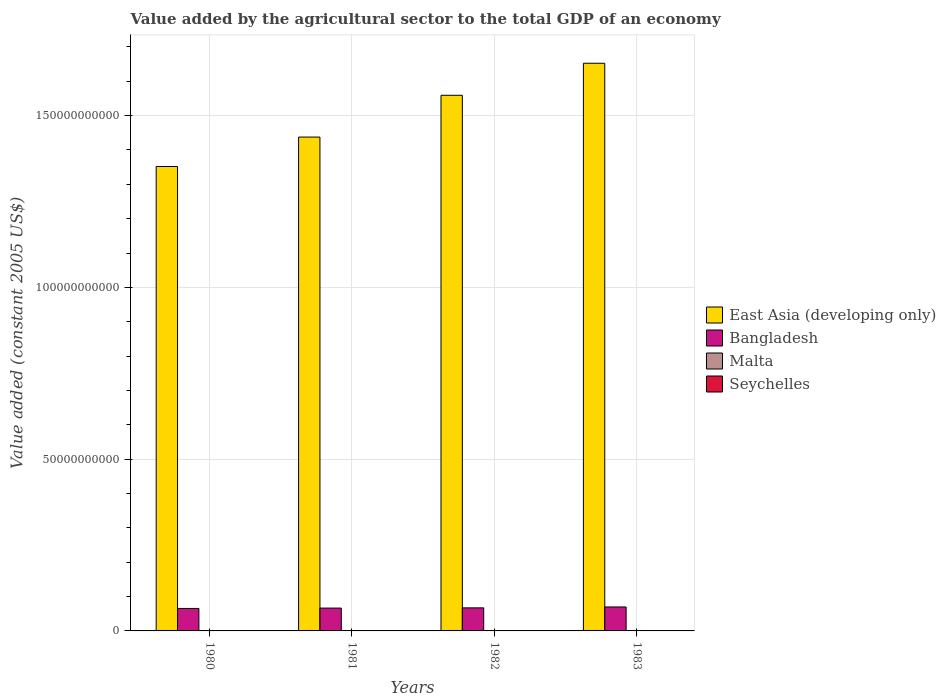How many groups of bars are there?
Your answer should be compact. 4. Are the number of bars per tick equal to the number of legend labels?
Make the answer very short. Yes. Are the number of bars on each tick of the X-axis equal?
Your answer should be compact. Yes. How many bars are there on the 2nd tick from the left?
Provide a short and direct response. 4. What is the label of the 4th group of bars from the left?
Your answer should be compact. 1983. What is the value added by the agricultural sector in Bangladesh in 1982?
Provide a succinct answer. 6.71e+09. Across all years, what is the maximum value added by the agricultural sector in Bangladesh?
Make the answer very short. 6.97e+09. Across all years, what is the minimum value added by the agricultural sector in Bangladesh?
Your response must be concise. 6.54e+09. In which year was the value added by the agricultural sector in Seychelles minimum?
Ensure brevity in your answer.  1982. What is the total value added by the agricultural sector in Bangladesh in the graph?
Give a very brief answer. 2.69e+1. What is the difference between the value added by the agricultural sector in Bangladesh in 1980 and that in 1983?
Offer a terse response. -4.32e+08. What is the difference between the value added by the agricultural sector in Bangladesh in 1981 and the value added by the agricultural sector in East Asia (developing only) in 1980?
Your response must be concise. -1.29e+11. What is the average value added by the agricultural sector in Bangladesh per year?
Ensure brevity in your answer.  6.72e+09. In the year 1980, what is the difference between the value added by the agricultural sector in Seychelles and value added by the agricultural sector in Bangladesh?
Ensure brevity in your answer.  -6.51e+09. What is the ratio of the value added by the agricultural sector in Bangladesh in 1981 to that in 1983?
Provide a short and direct response. 0.95. Is the value added by the agricultural sector in Seychelles in 1980 less than that in 1983?
Your response must be concise. Yes. Is the difference between the value added by the agricultural sector in Seychelles in 1980 and 1983 greater than the difference between the value added by the agricultural sector in Bangladesh in 1980 and 1983?
Your response must be concise. Yes. What is the difference between the highest and the second highest value added by the agricultural sector in Malta?
Offer a terse response. 1.11e+07. What is the difference between the highest and the lowest value added by the agricultural sector in Bangladesh?
Make the answer very short. 4.32e+08. In how many years, is the value added by the agricultural sector in Bangladesh greater than the average value added by the agricultural sector in Bangladesh taken over all years?
Keep it short and to the point. 1. What does the 1st bar from the right in 1981 represents?
Your answer should be compact. Seychelles. Is it the case that in every year, the sum of the value added by the agricultural sector in East Asia (developing only) and value added by the agricultural sector in Bangladesh is greater than the value added by the agricultural sector in Malta?
Your answer should be compact. Yes. How many bars are there?
Your answer should be very brief. 16. Are all the bars in the graph horizontal?
Your answer should be compact. No. Are the values on the major ticks of Y-axis written in scientific E-notation?
Offer a terse response. No. Does the graph contain any zero values?
Give a very brief answer. No. Does the graph contain grids?
Keep it short and to the point. Yes. Where does the legend appear in the graph?
Provide a succinct answer. Center right. How many legend labels are there?
Make the answer very short. 4. How are the legend labels stacked?
Provide a succinct answer. Vertical. What is the title of the graph?
Your answer should be compact. Value added by the agricultural sector to the total GDP of an economy. Does "Dominican Republic" appear as one of the legend labels in the graph?
Offer a very short reply. No. What is the label or title of the Y-axis?
Provide a succinct answer. Value added (constant 2005 US$). What is the Value added (constant 2005 US$) in East Asia (developing only) in 1980?
Ensure brevity in your answer.  1.35e+11. What is the Value added (constant 2005 US$) of Bangladesh in 1980?
Offer a very short reply. 6.54e+09. What is the Value added (constant 2005 US$) in Malta in 1980?
Your response must be concise. 8.12e+07. What is the Value added (constant 2005 US$) in Seychelles in 1980?
Provide a short and direct response. 3.19e+07. What is the Value added (constant 2005 US$) in East Asia (developing only) in 1981?
Provide a succinct answer. 1.44e+11. What is the Value added (constant 2005 US$) in Bangladesh in 1981?
Your answer should be compact. 6.65e+09. What is the Value added (constant 2005 US$) of Malta in 1981?
Give a very brief answer. 8.53e+07. What is the Value added (constant 2005 US$) in Seychelles in 1981?
Give a very brief answer. 3.42e+07. What is the Value added (constant 2005 US$) of East Asia (developing only) in 1982?
Provide a succinct answer. 1.56e+11. What is the Value added (constant 2005 US$) in Bangladesh in 1982?
Offer a terse response. 6.71e+09. What is the Value added (constant 2005 US$) in Malta in 1982?
Make the answer very short. 9.19e+07. What is the Value added (constant 2005 US$) of Seychelles in 1982?
Your response must be concise. 2.65e+07. What is the Value added (constant 2005 US$) of East Asia (developing only) in 1983?
Give a very brief answer. 1.65e+11. What is the Value added (constant 2005 US$) of Bangladesh in 1983?
Give a very brief answer. 6.97e+09. What is the Value added (constant 2005 US$) in Malta in 1983?
Provide a succinct answer. 1.03e+08. What is the Value added (constant 2005 US$) of Seychelles in 1983?
Make the answer very short. 3.30e+07. Across all years, what is the maximum Value added (constant 2005 US$) of East Asia (developing only)?
Give a very brief answer. 1.65e+11. Across all years, what is the maximum Value added (constant 2005 US$) of Bangladesh?
Your answer should be very brief. 6.97e+09. Across all years, what is the maximum Value added (constant 2005 US$) of Malta?
Make the answer very short. 1.03e+08. Across all years, what is the maximum Value added (constant 2005 US$) in Seychelles?
Your answer should be very brief. 3.42e+07. Across all years, what is the minimum Value added (constant 2005 US$) in East Asia (developing only)?
Make the answer very short. 1.35e+11. Across all years, what is the minimum Value added (constant 2005 US$) in Bangladesh?
Offer a terse response. 6.54e+09. Across all years, what is the minimum Value added (constant 2005 US$) of Malta?
Give a very brief answer. 8.12e+07. Across all years, what is the minimum Value added (constant 2005 US$) of Seychelles?
Your answer should be very brief. 2.65e+07. What is the total Value added (constant 2005 US$) in East Asia (developing only) in the graph?
Your answer should be compact. 6.00e+11. What is the total Value added (constant 2005 US$) in Bangladesh in the graph?
Give a very brief answer. 2.69e+1. What is the total Value added (constant 2005 US$) in Malta in the graph?
Ensure brevity in your answer.  3.61e+08. What is the total Value added (constant 2005 US$) of Seychelles in the graph?
Offer a terse response. 1.26e+08. What is the difference between the Value added (constant 2005 US$) in East Asia (developing only) in 1980 and that in 1981?
Ensure brevity in your answer.  -8.57e+09. What is the difference between the Value added (constant 2005 US$) of Bangladesh in 1980 and that in 1981?
Your answer should be compact. -1.03e+08. What is the difference between the Value added (constant 2005 US$) in Malta in 1980 and that in 1981?
Your answer should be very brief. -4.05e+06. What is the difference between the Value added (constant 2005 US$) in Seychelles in 1980 and that in 1981?
Your response must be concise. -2.31e+06. What is the difference between the Value added (constant 2005 US$) in East Asia (developing only) in 1980 and that in 1982?
Give a very brief answer. -2.07e+1. What is the difference between the Value added (constant 2005 US$) of Bangladesh in 1980 and that in 1982?
Provide a succinct answer. -1.71e+08. What is the difference between the Value added (constant 2005 US$) of Malta in 1980 and that in 1982?
Offer a terse response. -1.07e+07. What is the difference between the Value added (constant 2005 US$) of Seychelles in 1980 and that in 1982?
Ensure brevity in your answer.  5.41e+06. What is the difference between the Value added (constant 2005 US$) in East Asia (developing only) in 1980 and that in 1983?
Your answer should be compact. -3.01e+1. What is the difference between the Value added (constant 2005 US$) of Bangladesh in 1980 and that in 1983?
Give a very brief answer. -4.32e+08. What is the difference between the Value added (constant 2005 US$) of Malta in 1980 and that in 1983?
Offer a very short reply. -2.18e+07. What is the difference between the Value added (constant 2005 US$) of Seychelles in 1980 and that in 1983?
Provide a short and direct response. -1.09e+06. What is the difference between the Value added (constant 2005 US$) in East Asia (developing only) in 1981 and that in 1982?
Your answer should be compact. -1.22e+1. What is the difference between the Value added (constant 2005 US$) in Bangladesh in 1981 and that in 1982?
Your answer should be very brief. -6.80e+07. What is the difference between the Value added (constant 2005 US$) of Malta in 1981 and that in 1982?
Provide a succinct answer. -6.64e+06. What is the difference between the Value added (constant 2005 US$) of Seychelles in 1981 and that in 1982?
Keep it short and to the point. 7.73e+06. What is the difference between the Value added (constant 2005 US$) of East Asia (developing only) in 1981 and that in 1983?
Make the answer very short. -2.15e+1. What is the difference between the Value added (constant 2005 US$) of Bangladesh in 1981 and that in 1983?
Make the answer very short. -3.29e+08. What is the difference between the Value added (constant 2005 US$) of Malta in 1981 and that in 1983?
Ensure brevity in your answer.  -1.77e+07. What is the difference between the Value added (constant 2005 US$) of Seychelles in 1981 and that in 1983?
Offer a terse response. 1.23e+06. What is the difference between the Value added (constant 2005 US$) in East Asia (developing only) in 1982 and that in 1983?
Offer a very short reply. -9.32e+09. What is the difference between the Value added (constant 2005 US$) in Bangladesh in 1982 and that in 1983?
Ensure brevity in your answer.  -2.61e+08. What is the difference between the Value added (constant 2005 US$) of Malta in 1982 and that in 1983?
Provide a succinct answer. -1.11e+07. What is the difference between the Value added (constant 2005 US$) in Seychelles in 1982 and that in 1983?
Offer a terse response. -6.50e+06. What is the difference between the Value added (constant 2005 US$) of East Asia (developing only) in 1980 and the Value added (constant 2005 US$) of Bangladesh in 1981?
Ensure brevity in your answer.  1.29e+11. What is the difference between the Value added (constant 2005 US$) in East Asia (developing only) in 1980 and the Value added (constant 2005 US$) in Malta in 1981?
Provide a succinct answer. 1.35e+11. What is the difference between the Value added (constant 2005 US$) in East Asia (developing only) in 1980 and the Value added (constant 2005 US$) in Seychelles in 1981?
Provide a short and direct response. 1.35e+11. What is the difference between the Value added (constant 2005 US$) of Bangladesh in 1980 and the Value added (constant 2005 US$) of Malta in 1981?
Provide a succinct answer. 6.46e+09. What is the difference between the Value added (constant 2005 US$) of Bangladesh in 1980 and the Value added (constant 2005 US$) of Seychelles in 1981?
Make the answer very short. 6.51e+09. What is the difference between the Value added (constant 2005 US$) in Malta in 1980 and the Value added (constant 2005 US$) in Seychelles in 1981?
Provide a short and direct response. 4.70e+07. What is the difference between the Value added (constant 2005 US$) of East Asia (developing only) in 1980 and the Value added (constant 2005 US$) of Bangladesh in 1982?
Offer a very short reply. 1.28e+11. What is the difference between the Value added (constant 2005 US$) in East Asia (developing only) in 1980 and the Value added (constant 2005 US$) in Malta in 1982?
Offer a very short reply. 1.35e+11. What is the difference between the Value added (constant 2005 US$) in East Asia (developing only) in 1980 and the Value added (constant 2005 US$) in Seychelles in 1982?
Offer a terse response. 1.35e+11. What is the difference between the Value added (constant 2005 US$) of Bangladesh in 1980 and the Value added (constant 2005 US$) of Malta in 1982?
Your answer should be very brief. 6.45e+09. What is the difference between the Value added (constant 2005 US$) of Bangladesh in 1980 and the Value added (constant 2005 US$) of Seychelles in 1982?
Your answer should be compact. 6.52e+09. What is the difference between the Value added (constant 2005 US$) in Malta in 1980 and the Value added (constant 2005 US$) in Seychelles in 1982?
Your response must be concise. 5.47e+07. What is the difference between the Value added (constant 2005 US$) in East Asia (developing only) in 1980 and the Value added (constant 2005 US$) in Bangladesh in 1983?
Provide a succinct answer. 1.28e+11. What is the difference between the Value added (constant 2005 US$) in East Asia (developing only) in 1980 and the Value added (constant 2005 US$) in Malta in 1983?
Your answer should be very brief. 1.35e+11. What is the difference between the Value added (constant 2005 US$) of East Asia (developing only) in 1980 and the Value added (constant 2005 US$) of Seychelles in 1983?
Provide a short and direct response. 1.35e+11. What is the difference between the Value added (constant 2005 US$) of Bangladesh in 1980 and the Value added (constant 2005 US$) of Malta in 1983?
Offer a very short reply. 6.44e+09. What is the difference between the Value added (constant 2005 US$) in Bangladesh in 1980 and the Value added (constant 2005 US$) in Seychelles in 1983?
Ensure brevity in your answer.  6.51e+09. What is the difference between the Value added (constant 2005 US$) of Malta in 1980 and the Value added (constant 2005 US$) of Seychelles in 1983?
Keep it short and to the point. 4.82e+07. What is the difference between the Value added (constant 2005 US$) in East Asia (developing only) in 1981 and the Value added (constant 2005 US$) in Bangladesh in 1982?
Provide a succinct answer. 1.37e+11. What is the difference between the Value added (constant 2005 US$) in East Asia (developing only) in 1981 and the Value added (constant 2005 US$) in Malta in 1982?
Provide a short and direct response. 1.44e+11. What is the difference between the Value added (constant 2005 US$) of East Asia (developing only) in 1981 and the Value added (constant 2005 US$) of Seychelles in 1982?
Your answer should be very brief. 1.44e+11. What is the difference between the Value added (constant 2005 US$) of Bangladesh in 1981 and the Value added (constant 2005 US$) of Malta in 1982?
Your answer should be compact. 6.55e+09. What is the difference between the Value added (constant 2005 US$) of Bangladesh in 1981 and the Value added (constant 2005 US$) of Seychelles in 1982?
Offer a terse response. 6.62e+09. What is the difference between the Value added (constant 2005 US$) in Malta in 1981 and the Value added (constant 2005 US$) in Seychelles in 1982?
Ensure brevity in your answer.  5.87e+07. What is the difference between the Value added (constant 2005 US$) in East Asia (developing only) in 1981 and the Value added (constant 2005 US$) in Bangladesh in 1983?
Provide a short and direct response. 1.37e+11. What is the difference between the Value added (constant 2005 US$) in East Asia (developing only) in 1981 and the Value added (constant 2005 US$) in Malta in 1983?
Make the answer very short. 1.44e+11. What is the difference between the Value added (constant 2005 US$) in East Asia (developing only) in 1981 and the Value added (constant 2005 US$) in Seychelles in 1983?
Ensure brevity in your answer.  1.44e+11. What is the difference between the Value added (constant 2005 US$) in Bangladesh in 1981 and the Value added (constant 2005 US$) in Malta in 1983?
Provide a short and direct response. 6.54e+09. What is the difference between the Value added (constant 2005 US$) of Bangladesh in 1981 and the Value added (constant 2005 US$) of Seychelles in 1983?
Ensure brevity in your answer.  6.61e+09. What is the difference between the Value added (constant 2005 US$) in Malta in 1981 and the Value added (constant 2005 US$) in Seychelles in 1983?
Your answer should be very brief. 5.22e+07. What is the difference between the Value added (constant 2005 US$) in East Asia (developing only) in 1982 and the Value added (constant 2005 US$) in Bangladesh in 1983?
Make the answer very short. 1.49e+11. What is the difference between the Value added (constant 2005 US$) of East Asia (developing only) in 1982 and the Value added (constant 2005 US$) of Malta in 1983?
Offer a terse response. 1.56e+11. What is the difference between the Value added (constant 2005 US$) in East Asia (developing only) in 1982 and the Value added (constant 2005 US$) in Seychelles in 1983?
Offer a very short reply. 1.56e+11. What is the difference between the Value added (constant 2005 US$) in Bangladesh in 1982 and the Value added (constant 2005 US$) in Malta in 1983?
Ensure brevity in your answer.  6.61e+09. What is the difference between the Value added (constant 2005 US$) of Bangladesh in 1982 and the Value added (constant 2005 US$) of Seychelles in 1983?
Your answer should be compact. 6.68e+09. What is the difference between the Value added (constant 2005 US$) of Malta in 1982 and the Value added (constant 2005 US$) of Seychelles in 1983?
Provide a short and direct response. 5.89e+07. What is the average Value added (constant 2005 US$) in East Asia (developing only) per year?
Your answer should be very brief. 1.50e+11. What is the average Value added (constant 2005 US$) of Bangladesh per year?
Provide a short and direct response. 6.72e+09. What is the average Value added (constant 2005 US$) in Malta per year?
Make the answer very short. 9.03e+07. What is the average Value added (constant 2005 US$) in Seychelles per year?
Ensure brevity in your answer.  3.14e+07. In the year 1980, what is the difference between the Value added (constant 2005 US$) of East Asia (developing only) and Value added (constant 2005 US$) of Bangladesh?
Give a very brief answer. 1.29e+11. In the year 1980, what is the difference between the Value added (constant 2005 US$) in East Asia (developing only) and Value added (constant 2005 US$) in Malta?
Offer a terse response. 1.35e+11. In the year 1980, what is the difference between the Value added (constant 2005 US$) in East Asia (developing only) and Value added (constant 2005 US$) in Seychelles?
Give a very brief answer. 1.35e+11. In the year 1980, what is the difference between the Value added (constant 2005 US$) of Bangladesh and Value added (constant 2005 US$) of Malta?
Offer a terse response. 6.46e+09. In the year 1980, what is the difference between the Value added (constant 2005 US$) in Bangladesh and Value added (constant 2005 US$) in Seychelles?
Make the answer very short. 6.51e+09. In the year 1980, what is the difference between the Value added (constant 2005 US$) in Malta and Value added (constant 2005 US$) in Seychelles?
Offer a terse response. 4.93e+07. In the year 1981, what is the difference between the Value added (constant 2005 US$) in East Asia (developing only) and Value added (constant 2005 US$) in Bangladesh?
Provide a succinct answer. 1.37e+11. In the year 1981, what is the difference between the Value added (constant 2005 US$) in East Asia (developing only) and Value added (constant 2005 US$) in Malta?
Offer a terse response. 1.44e+11. In the year 1981, what is the difference between the Value added (constant 2005 US$) in East Asia (developing only) and Value added (constant 2005 US$) in Seychelles?
Offer a very short reply. 1.44e+11. In the year 1981, what is the difference between the Value added (constant 2005 US$) of Bangladesh and Value added (constant 2005 US$) of Malta?
Keep it short and to the point. 6.56e+09. In the year 1981, what is the difference between the Value added (constant 2005 US$) in Bangladesh and Value added (constant 2005 US$) in Seychelles?
Offer a terse response. 6.61e+09. In the year 1981, what is the difference between the Value added (constant 2005 US$) of Malta and Value added (constant 2005 US$) of Seychelles?
Offer a terse response. 5.10e+07. In the year 1982, what is the difference between the Value added (constant 2005 US$) in East Asia (developing only) and Value added (constant 2005 US$) in Bangladesh?
Give a very brief answer. 1.49e+11. In the year 1982, what is the difference between the Value added (constant 2005 US$) of East Asia (developing only) and Value added (constant 2005 US$) of Malta?
Your response must be concise. 1.56e+11. In the year 1982, what is the difference between the Value added (constant 2005 US$) in East Asia (developing only) and Value added (constant 2005 US$) in Seychelles?
Offer a very short reply. 1.56e+11. In the year 1982, what is the difference between the Value added (constant 2005 US$) in Bangladesh and Value added (constant 2005 US$) in Malta?
Ensure brevity in your answer.  6.62e+09. In the year 1982, what is the difference between the Value added (constant 2005 US$) of Bangladesh and Value added (constant 2005 US$) of Seychelles?
Keep it short and to the point. 6.69e+09. In the year 1982, what is the difference between the Value added (constant 2005 US$) of Malta and Value added (constant 2005 US$) of Seychelles?
Your response must be concise. 6.54e+07. In the year 1983, what is the difference between the Value added (constant 2005 US$) of East Asia (developing only) and Value added (constant 2005 US$) of Bangladesh?
Keep it short and to the point. 1.58e+11. In the year 1983, what is the difference between the Value added (constant 2005 US$) in East Asia (developing only) and Value added (constant 2005 US$) in Malta?
Make the answer very short. 1.65e+11. In the year 1983, what is the difference between the Value added (constant 2005 US$) of East Asia (developing only) and Value added (constant 2005 US$) of Seychelles?
Your response must be concise. 1.65e+11. In the year 1983, what is the difference between the Value added (constant 2005 US$) of Bangladesh and Value added (constant 2005 US$) of Malta?
Your answer should be very brief. 6.87e+09. In the year 1983, what is the difference between the Value added (constant 2005 US$) of Bangladesh and Value added (constant 2005 US$) of Seychelles?
Ensure brevity in your answer.  6.94e+09. In the year 1983, what is the difference between the Value added (constant 2005 US$) in Malta and Value added (constant 2005 US$) in Seychelles?
Your response must be concise. 7.00e+07. What is the ratio of the Value added (constant 2005 US$) in East Asia (developing only) in 1980 to that in 1981?
Provide a succinct answer. 0.94. What is the ratio of the Value added (constant 2005 US$) of Bangladesh in 1980 to that in 1981?
Provide a succinct answer. 0.98. What is the ratio of the Value added (constant 2005 US$) of Malta in 1980 to that in 1981?
Offer a very short reply. 0.95. What is the ratio of the Value added (constant 2005 US$) of Seychelles in 1980 to that in 1981?
Offer a very short reply. 0.93. What is the ratio of the Value added (constant 2005 US$) in East Asia (developing only) in 1980 to that in 1982?
Your answer should be very brief. 0.87. What is the ratio of the Value added (constant 2005 US$) in Bangladesh in 1980 to that in 1982?
Provide a short and direct response. 0.97. What is the ratio of the Value added (constant 2005 US$) in Malta in 1980 to that in 1982?
Ensure brevity in your answer.  0.88. What is the ratio of the Value added (constant 2005 US$) of Seychelles in 1980 to that in 1982?
Give a very brief answer. 1.2. What is the ratio of the Value added (constant 2005 US$) in East Asia (developing only) in 1980 to that in 1983?
Offer a very short reply. 0.82. What is the ratio of the Value added (constant 2005 US$) of Bangladesh in 1980 to that in 1983?
Your answer should be very brief. 0.94. What is the ratio of the Value added (constant 2005 US$) of Malta in 1980 to that in 1983?
Ensure brevity in your answer.  0.79. What is the ratio of the Value added (constant 2005 US$) of Seychelles in 1980 to that in 1983?
Your answer should be very brief. 0.97. What is the ratio of the Value added (constant 2005 US$) of East Asia (developing only) in 1981 to that in 1982?
Your response must be concise. 0.92. What is the ratio of the Value added (constant 2005 US$) in Malta in 1981 to that in 1982?
Provide a succinct answer. 0.93. What is the ratio of the Value added (constant 2005 US$) of Seychelles in 1981 to that in 1982?
Ensure brevity in your answer.  1.29. What is the ratio of the Value added (constant 2005 US$) of East Asia (developing only) in 1981 to that in 1983?
Offer a terse response. 0.87. What is the ratio of the Value added (constant 2005 US$) in Bangladesh in 1981 to that in 1983?
Keep it short and to the point. 0.95. What is the ratio of the Value added (constant 2005 US$) in Malta in 1981 to that in 1983?
Offer a terse response. 0.83. What is the ratio of the Value added (constant 2005 US$) in Seychelles in 1981 to that in 1983?
Offer a terse response. 1.04. What is the ratio of the Value added (constant 2005 US$) of East Asia (developing only) in 1982 to that in 1983?
Provide a short and direct response. 0.94. What is the ratio of the Value added (constant 2005 US$) of Bangladesh in 1982 to that in 1983?
Provide a short and direct response. 0.96. What is the ratio of the Value added (constant 2005 US$) of Malta in 1982 to that in 1983?
Provide a succinct answer. 0.89. What is the ratio of the Value added (constant 2005 US$) in Seychelles in 1982 to that in 1983?
Give a very brief answer. 0.8. What is the difference between the highest and the second highest Value added (constant 2005 US$) in East Asia (developing only)?
Your answer should be compact. 9.32e+09. What is the difference between the highest and the second highest Value added (constant 2005 US$) of Bangladesh?
Keep it short and to the point. 2.61e+08. What is the difference between the highest and the second highest Value added (constant 2005 US$) of Malta?
Make the answer very short. 1.11e+07. What is the difference between the highest and the second highest Value added (constant 2005 US$) of Seychelles?
Your answer should be very brief. 1.23e+06. What is the difference between the highest and the lowest Value added (constant 2005 US$) of East Asia (developing only)?
Offer a very short reply. 3.01e+1. What is the difference between the highest and the lowest Value added (constant 2005 US$) in Bangladesh?
Your answer should be compact. 4.32e+08. What is the difference between the highest and the lowest Value added (constant 2005 US$) in Malta?
Your response must be concise. 2.18e+07. What is the difference between the highest and the lowest Value added (constant 2005 US$) in Seychelles?
Offer a terse response. 7.73e+06. 